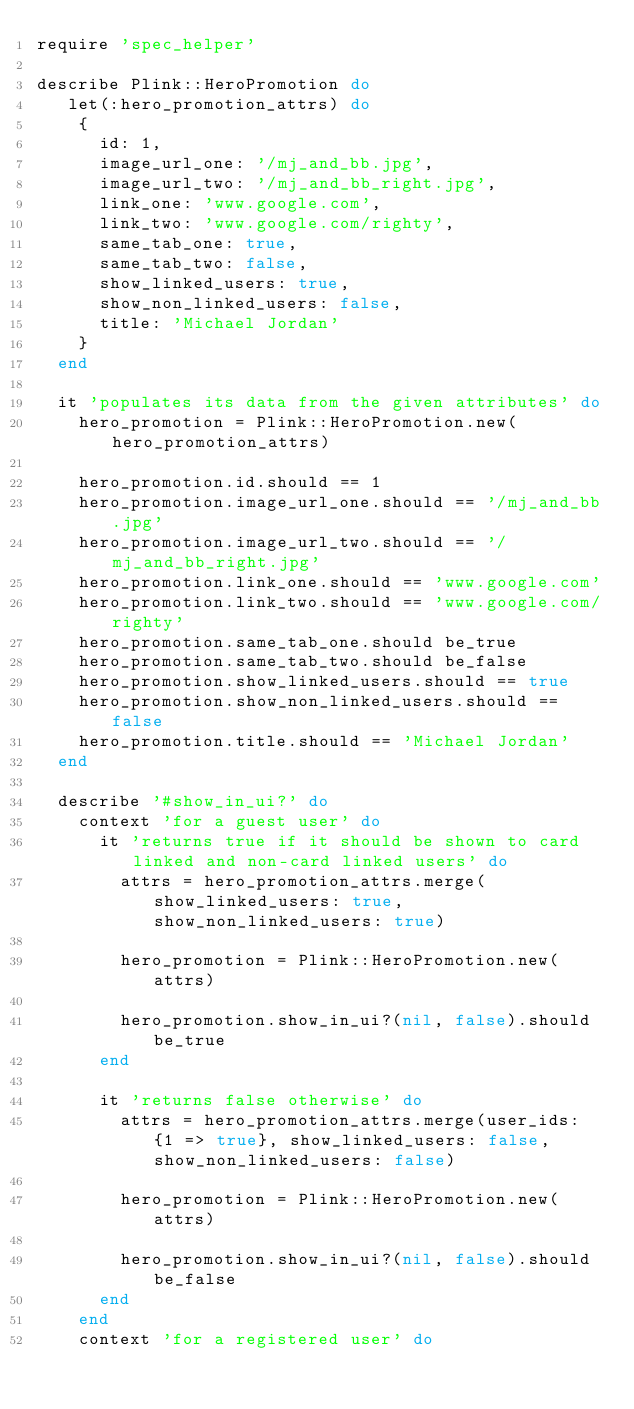Convert code to text. <code><loc_0><loc_0><loc_500><loc_500><_Ruby_>require 'spec_helper'

describe Plink::HeroPromotion do
   let(:hero_promotion_attrs) do
    {
      id: 1,
      image_url_one: '/mj_and_bb.jpg',
      image_url_two: '/mj_and_bb_right.jpg',
      link_one: 'www.google.com',
      link_two: 'www.google.com/righty',
      same_tab_one: true,
      same_tab_two: false,
      show_linked_users: true,
      show_non_linked_users: false,
      title: 'Michael Jordan'
    }
  end

  it 'populates its data from the given attributes' do
    hero_promotion = Plink::HeroPromotion.new(hero_promotion_attrs)

    hero_promotion.id.should == 1
    hero_promotion.image_url_one.should == '/mj_and_bb.jpg'
    hero_promotion.image_url_two.should == '/mj_and_bb_right.jpg'
    hero_promotion.link_one.should == 'www.google.com'
    hero_promotion.link_two.should == 'www.google.com/righty'
    hero_promotion.same_tab_one.should be_true
    hero_promotion.same_tab_two.should be_false
    hero_promotion.show_linked_users.should == true
    hero_promotion.show_non_linked_users.should == false
    hero_promotion.title.should == 'Michael Jordan'
  end

  describe '#show_in_ui?' do
    context 'for a guest user' do
      it 'returns true if it should be shown to card linked and non-card linked users' do
        attrs = hero_promotion_attrs.merge(show_linked_users: true, show_non_linked_users: true)

        hero_promotion = Plink::HeroPromotion.new(attrs)

        hero_promotion.show_in_ui?(nil, false).should be_true
      end

      it 'returns false otherwise' do
        attrs = hero_promotion_attrs.merge(user_ids: {1 => true}, show_linked_users: false, show_non_linked_users: false)

        hero_promotion = Plink::HeroPromotion.new(attrs)

        hero_promotion.show_in_ui?(nil, false).should be_false
      end
    end
    context 'for a registered user' do</code> 